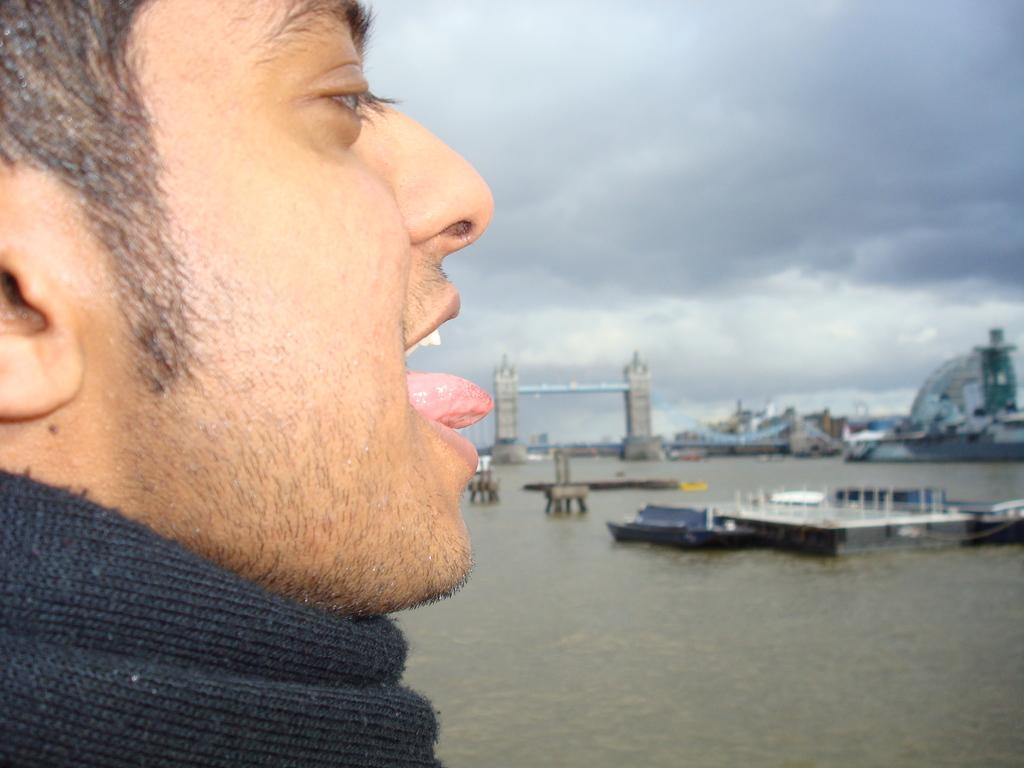What is the main subject of the image? There is a person in the image. What is the person wearing? The person is wearing a black dress. What is the person doing in the image? The person has opened their mouth and placed their tongue outside. What can be seen in the background of the image? There are buildings and water visible in the background of the image. How many lizards are crawling on the person's dress in the image? There are no lizards present in the image. What type of plantation can be seen in the background of the image? There is no plantation visible in the image; only buildings and water are present in the background. 